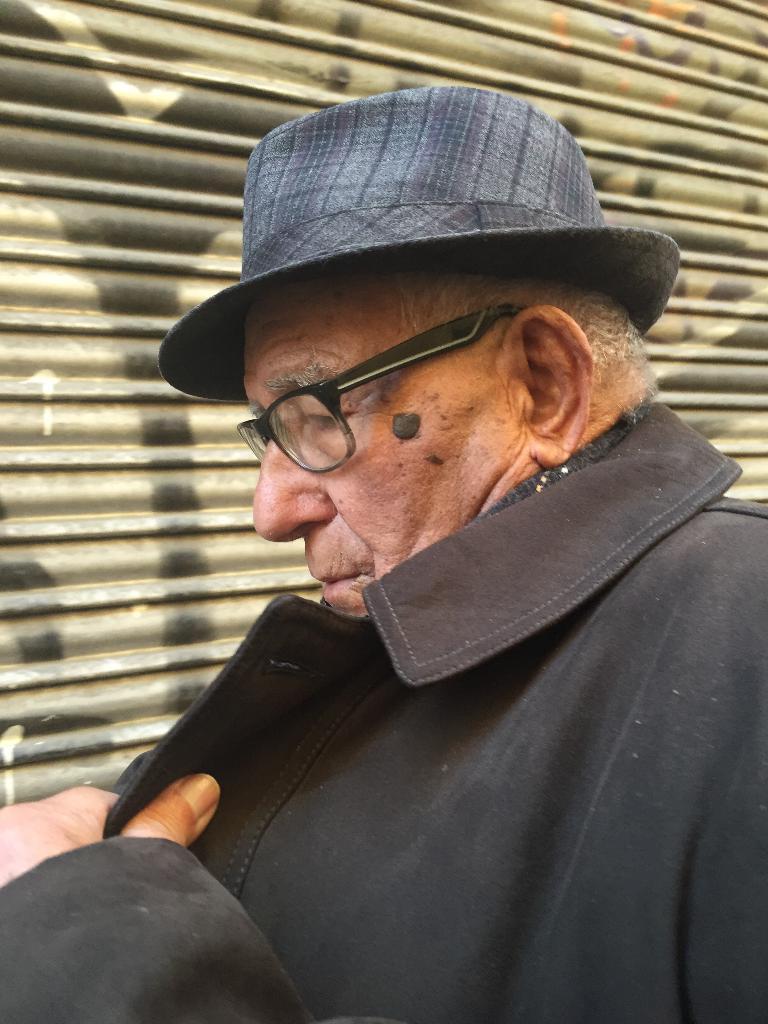How would you summarize this image in a sentence or two? This image consists of a man. He is wearing jacket, specs, and a hat. Jacket is in black color. There is a shutter behind him. 